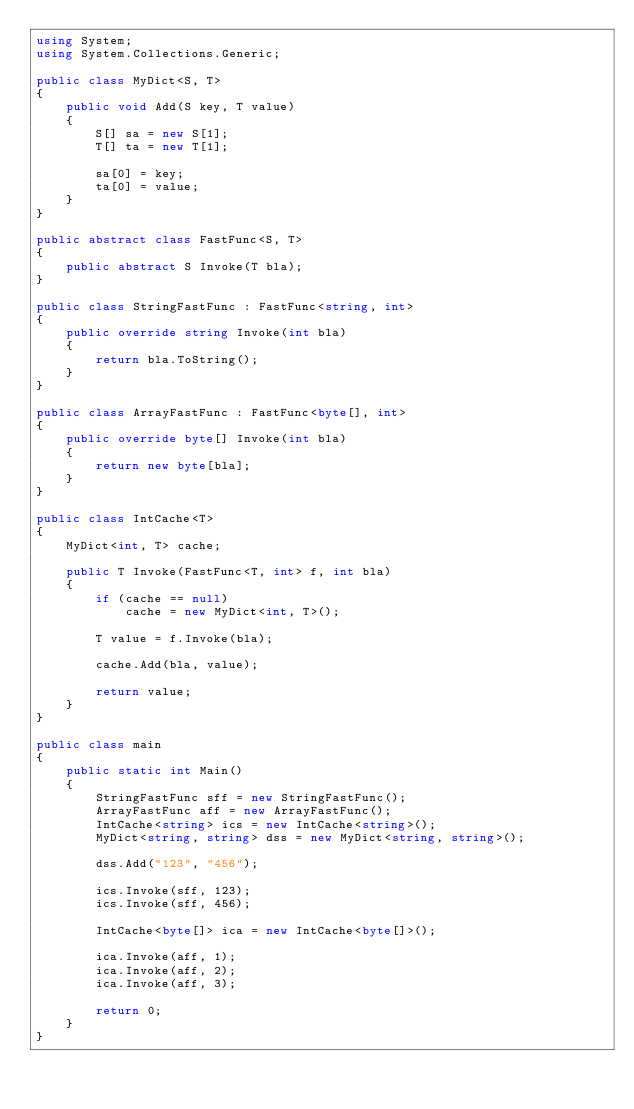<code> <loc_0><loc_0><loc_500><loc_500><_C#_>using System;
using System.Collections.Generic;

public class MyDict<S, T>
{
    public void Add(S key, T value)
    {
        S[] sa = new S[1];
        T[] ta = new T[1];

        sa[0] = key;
        ta[0] = value;
    }
}

public abstract class FastFunc<S, T>
{
    public abstract S Invoke(T bla);
}

public class StringFastFunc : FastFunc<string, int>
{
    public override string Invoke(int bla)
    {
        return bla.ToString();
    }
}

public class ArrayFastFunc : FastFunc<byte[], int>
{
    public override byte[] Invoke(int bla)
    {
        return new byte[bla];
    }
}

public class IntCache<T>
{
    MyDict<int, T> cache;

    public T Invoke(FastFunc<T, int> f, int bla)
    {
        if (cache == null)
            cache = new MyDict<int, T>();

        T value = f.Invoke(bla);

        cache.Add(bla, value);

        return value;
    }
}

public class main
{
    public static int Main()
    {
        StringFastFunc sff = new StringFastFunc();
        ArrayFastFunc aff = new ArrayFastFunc();
        IntCache<string> ics = new IntCache<string>();
        MyDict<string, string> dss = new MyDict<string, string>();

        dss.Add("123", "456");

        ics.Invoke(sff, 123);
        ics.Invoke(sff, 456);

        IntCache<byte[]> ica = new IntCache<byte[]>();

        ica.Invoke(aff, 1);
        ica.Invoke(aff, 2);
        ica.Invoke(aff, 3);

        return 0;
    }
}
</code> 